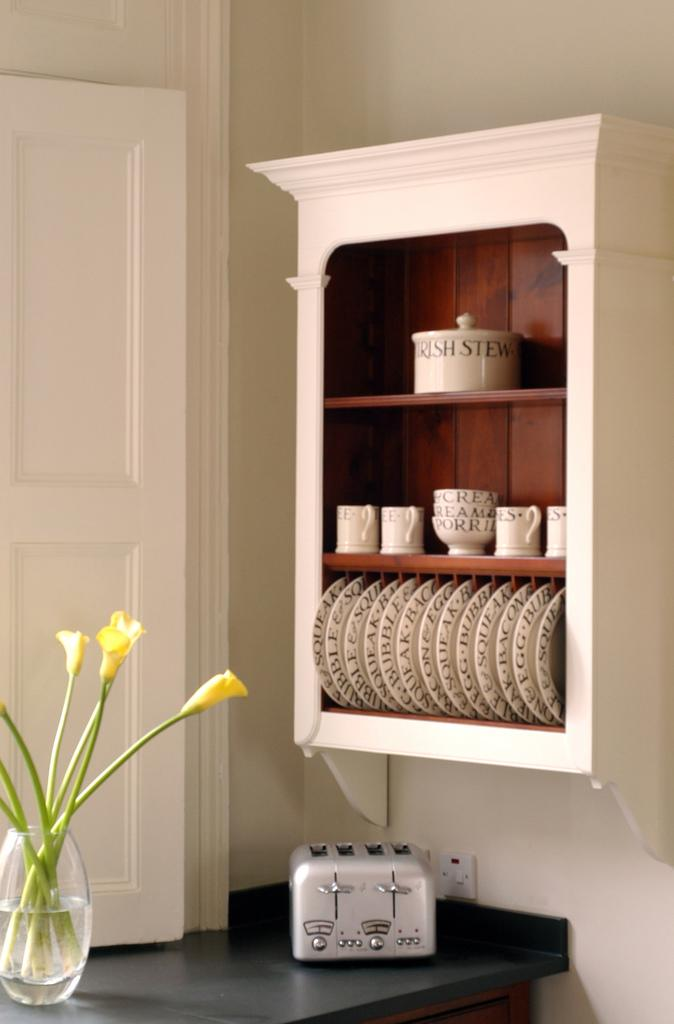Provide a one-sentence caption for the provided image. A four slice toaster under a plate rack that has a crock of Irish stew on the top shelf. 